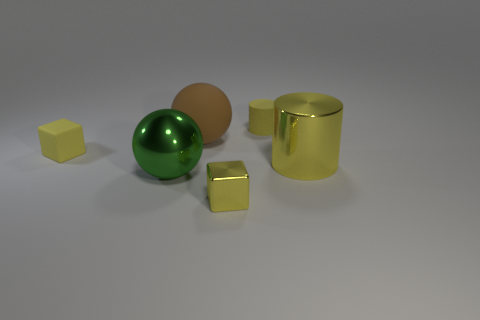How many yellow cylinders must be subtracted to get 1 yellow cylinders? 1 Add 4 small yellow matte cylinders. How many objects exist? 10 Subtract all balls. How many objects are left? 4 Add 2 green things. How many green things are left? 3 Add 4 shiny blocks. How many shiny blocks exist? 5 Subtract 0 yellow spheres. How many objects are left? 6 Subtract all tiny matte objects. Subtract all purple objects. How many objects are left? 4 